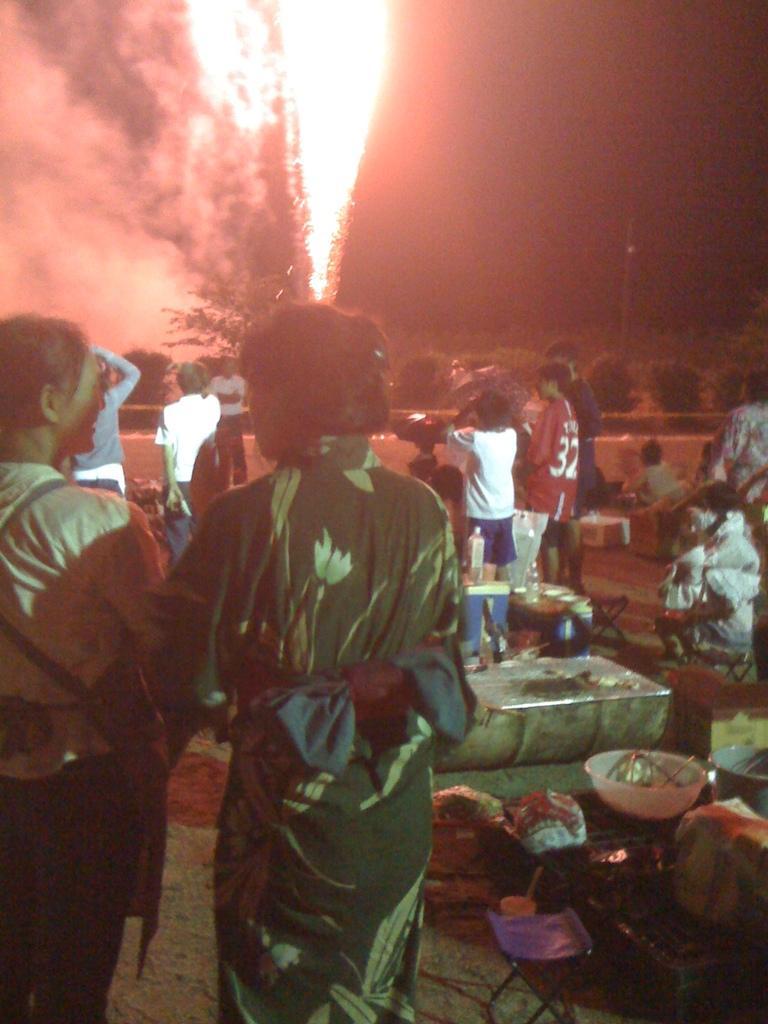Can you describe this image briefly? In this picture we can see two women standing in the front. Behind there is a group of people, standing and firing the crackers. 